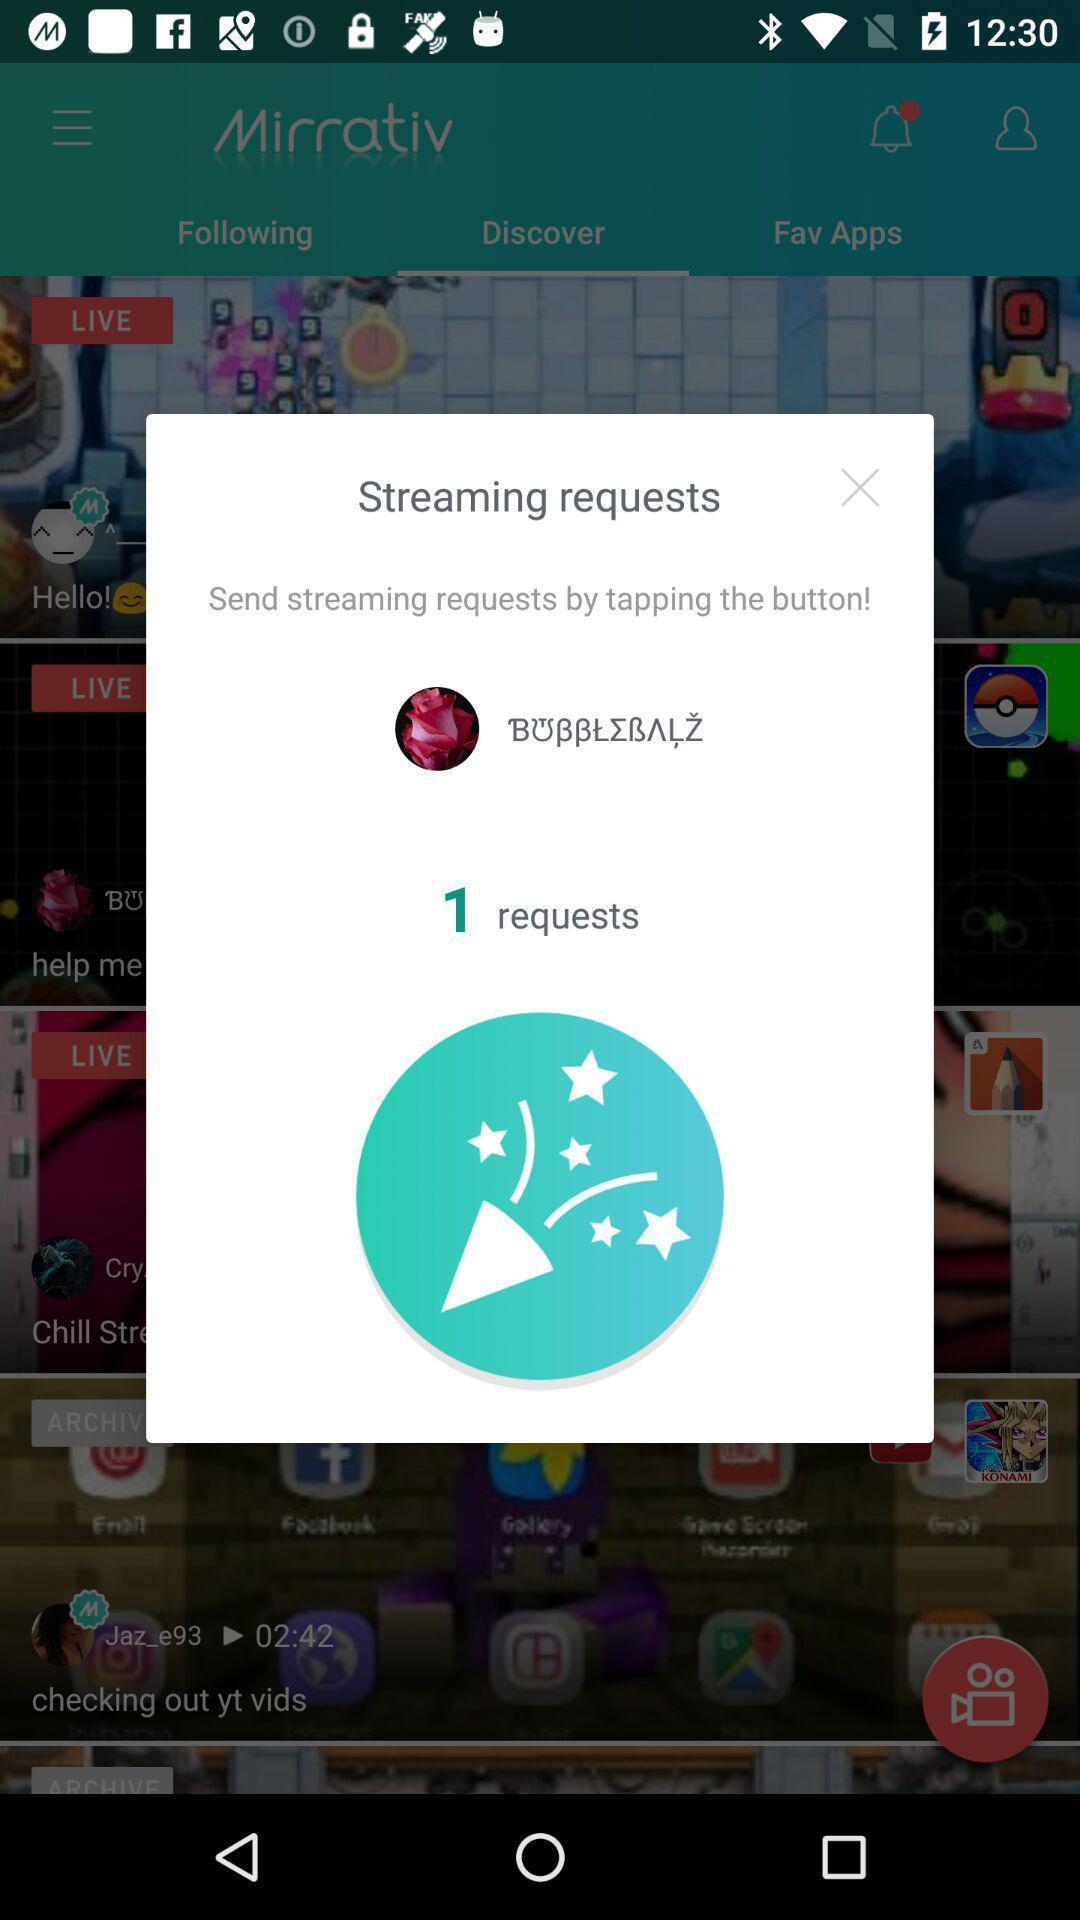Explain the elements present in this screenshot. Pop-up shows alert about stream requests. 